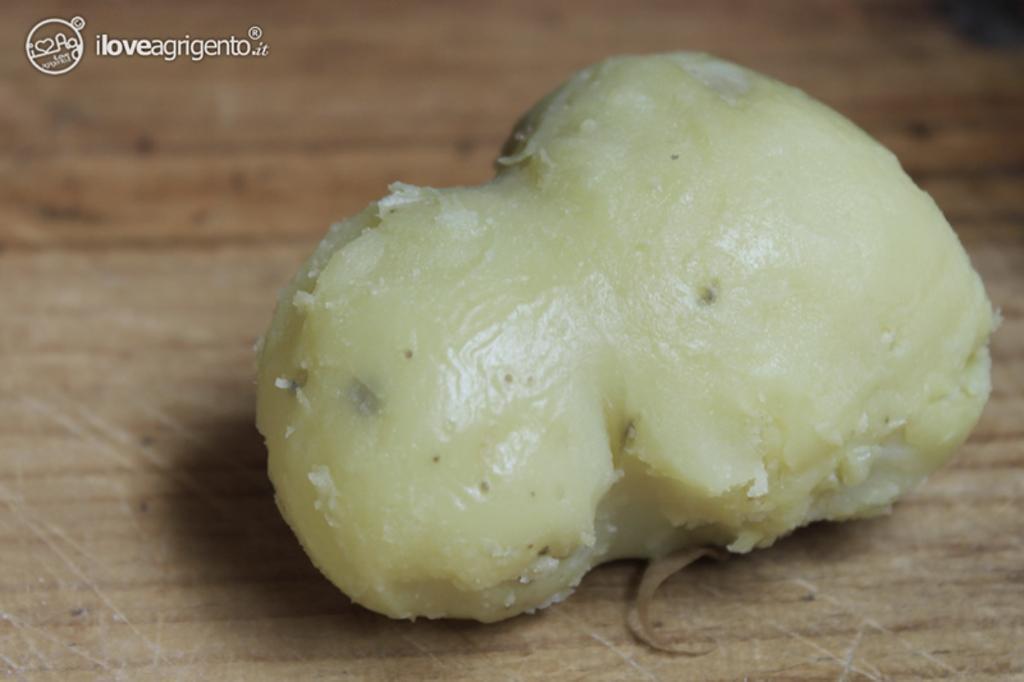In one or two sentences, can you explain what this image depicts? In this image I can see a vegetable in cream color. It is on the brown color surface. 